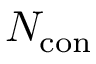Convert formula to latex. <formula><loc_0><loc_0><loc_500><loc_500>N _ { c o n }</formula> 